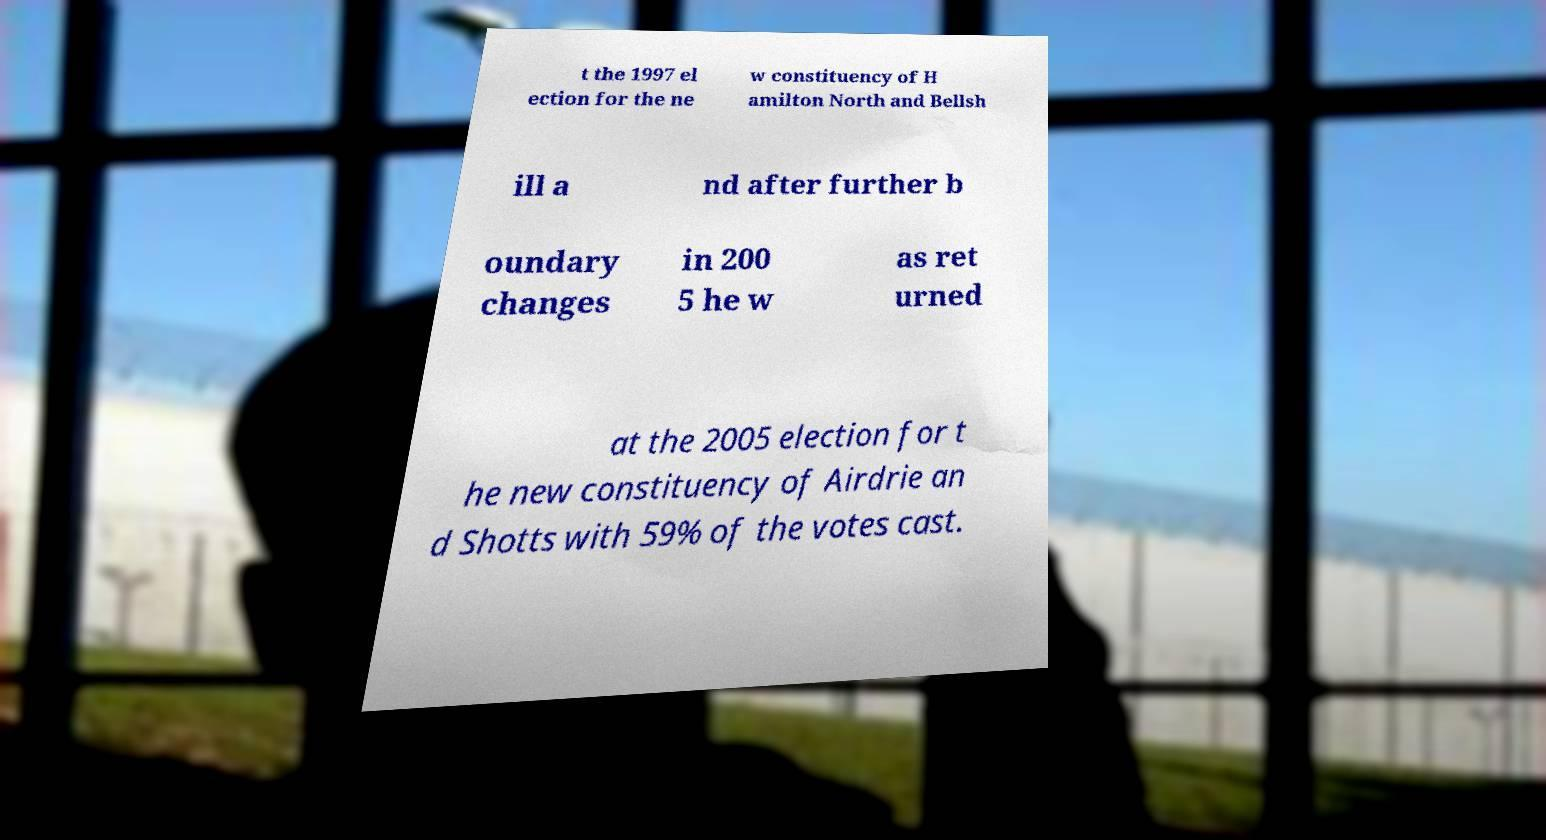There's text embedded in this image that I need extracted. Can you transcribe it verbatim? t the 1997 el ection for the ne w constituency of H amilton North and Bellsh ill a nd after further b oundary changes in 200 5 he w as ret urned at the 2005 election for t he new constituency of Airdrie an d Shotts with 59% of the votes cast. 